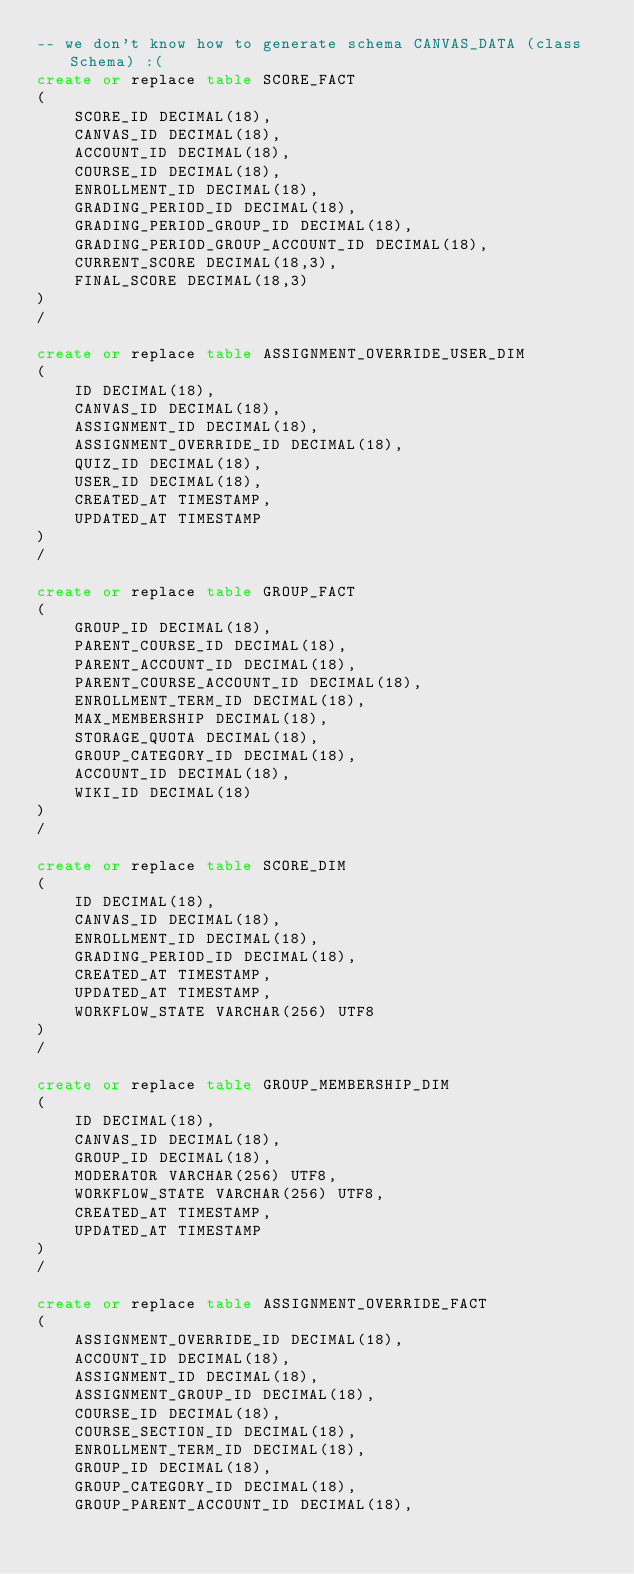<code> <loc_0><loc_0><loc_500><loc_500><_SQL_>-- we don't know how to generate schema CANVAS_DATA (class Schema) :(
create or replace table SCORE_FACT
(
	SCORE_ID DECIMAL(18),
	CANVAS_ID DECIMAL(18),
	ACCOUNT_ID DECIMAL(18),
	COURSE_ID DECIMAL(18),
	ENROLLMENT_ID DECIMAL(18),
	GRADING_PERIOD_ID DECIMAL(18),
	GRADING_PERIOD_GROUP_ID DECIMAL(18),
	GRADING_PERIOD_GROUP_ACCOUNT_ID DECIMAL(18),
	CURRENT_SCORE DECIMAL(18,3),
	FINAL_SCORE DECIMAL(18,3)
)
/

create or replace table ASSIGNMENT_OVERRIDE_USER_DIM
(
	ID DECIMAL(18),
	CANVAS_ID DECIMAL(18),
	ASSIGNMENT_ID DECIMAL(18),
	ASSIGNMENT_OVERRIDE_ID DECIMAL(18),
	QUIZ_ID DECIMAL(18),
	USER_ID DECIMAL(18),
	CREATED_AT TIMESTAMP,
	UPDATED_AT TIMESTAMP
)
/

create or replace table GROUP_FACT
(
	GROUP_ID DECIMAL(18),
	PARENT_COURSE_ID DECIMAL(18),
	PARENT_ACCOUNT_ID DECIMAL(18),
	PARENT_COURSE_ACCOUNT_ID DECIMAL(18),
	ENROLLMENT_TERM_ID DECIMAL(18),
	MAX_MEMBERSHIP DECIMAL(18),
	STORAGE_QUOTA DECIMAL(18),
	GROUP_CATEGORY_ID DECIMAL(18),
	ACCOUNT_ID DECIMAL(18),
	WIKI_ID DECIMAL(18)
)
/

create or replace table SCORE_DIM
(
	ID DECIMAL(18),
	CANVAS_ID DECIMAL(18),
	ENROLLMENT_ID DECIMAL(18),
	GRADING_PERIOD_ID DECIMAL(18),
	CREATED_AT TIMESTAMP,
	UPDATED_AT TIMESTAMP,
	WORKFLOW_STATE VARCHAR(256) UTF8
)
/

create or replace table GROUP_MEMBERSHIP_DIM
(
	ID DECIMAL(18),
	CANVAS_ID DECIMAL(18),
	GROUP_ID DECIMAL(18),
	MODERATOR VARCHAR(256) UTF8,
	WORKFLOW_STATE VARCHAR(256) UTF8,
	CREATED_AT TIMESTAMP,
	UPDATED_AT TIMESTAMP
)
/

create or replace table ASSIGNMENT_OVERRIDE_FACT
(
	ASSIGNMENT_OVERRIDE_ID DECIMAL(18),
	ACCOUNT_ID DECIMAL(18),
	ASSIGNMENT_ID DECIMAL(18),
	ASSIGNMENT_GROUP_ID DECIMAL(18),
	COURSE_ID DECIMAL(18),
	COURSE_SECTION_ID DECIMAL(18),
	ENROLLMENT_TERM_ID DECIMAL(18),
	GROUP_ID DECIMAL(18),
	GROUP_CATEGORY_ID DECIMAL(18),
	GROUP_PARENT_ACCOUNT_ID DECIMAL(18),</code> 